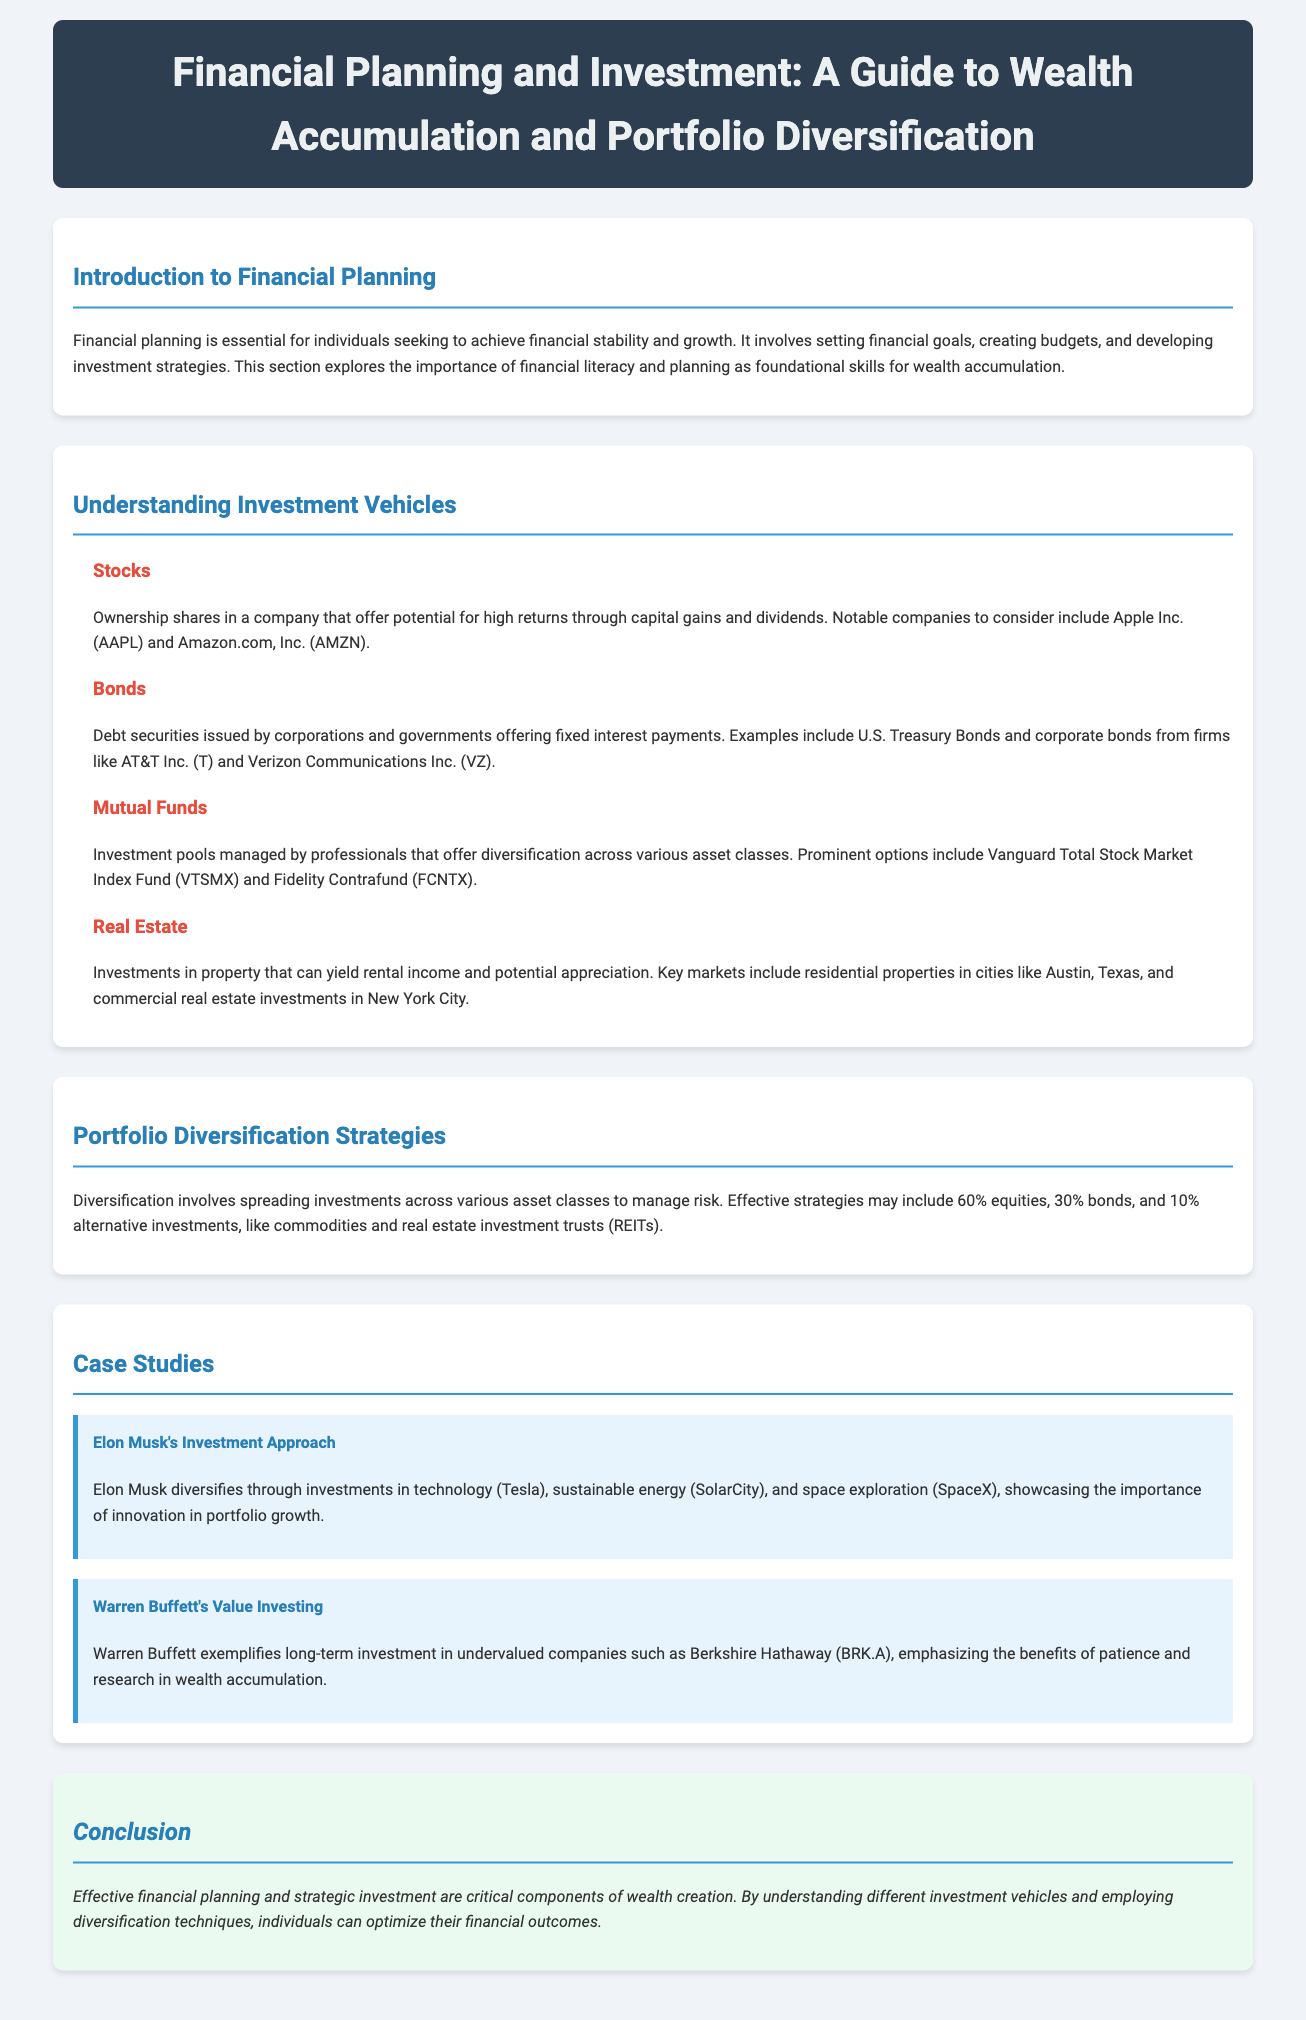what is the title of the document? The title of the document is stated at the top, providing a clear indication of its subject.
Answer: Financial Planning and Investment: A Guide to Wealth Accumulation and Portfolio Diversification who are two notable investors mentioned in the case studies? The case studies include two well-known investors whose strategies are highlighted, helping illustrate effective investment approaches.
Answer: Elon Musk, Warren Buffett what are the four types of investment vehicles listed? The document categorizes different investment options, summarizing their characteristics and providing examples.
Answer: Stocks, Bonds, Mutual Funds, Real Estate what is the recommended asset allocation for a diversified portfolio? The document discusses an effective diversification strategy, summarizing the distribution of various asset classes for managing risk.
Answer: 60% equities, 30% bonds, 10% alternative investments what does Elon Musk's investment approach emphasize? The case study describes how Musk combines various sectors to enhance portfolio growth, showcasing a specific investment philosophy.
Answer: Innovation in portfolio growth which investment fund is mentioned under Mutual Funds? The subsection on mutual funds includes specific examples of well-known investment funds available in the market.
Answer: Vanguard Total Stock Market Index Fund (VTSMX) 